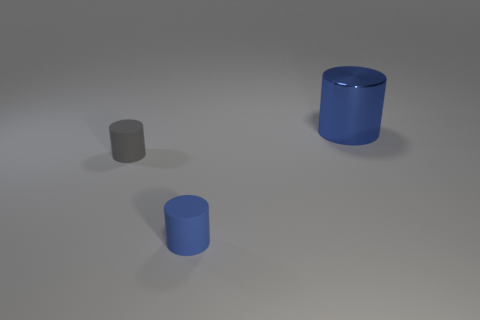Add 3 green balls. How many objects exist? 6 Subtract all gray cylinders. How many cylinders are left? 2 Subtract all small matte cylinders. How many cylinders are left? 1 Subtract all yellow balls. How many purple cylinders are left? 0 Subtract all small purple rubber cubes. Subtract all blue rubber objects. How many objects are left? 2 Add 2 blue things. How many blue things are left? 4 Add 2 blue metallic objects. How many blue metallic objects exist? 3 Subtract 0 cyan spheres. How many objects are left? 3 Subtract all red cylinders. Subtract all cyan blocks. How many cylinders are left? 3 